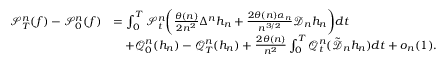Convert formula to latex. <formula><loc_0><loc_0><loc_500><loc_500>\begin{array} { r l } { \ m a t h s c r { S } _ { T } ^ { n } ( f ) - \ m a t h s c r { S } _ { 0 } ^ { n } ( f ) } & { = \int _ { 0 } ^ { T } \ m a t h s c r { S } _ { t } ^ { n } \left ( \frac { \theta ( n ) } { 2 n ^ { 2 } } \Delta ^ { n } h _ { n } + \frac { 2 \theta ( n ) \alpha _ { n } } { n ^ { 3 / 2 } } \ m a t h s c r { D } _ { n } h _ { n } \right ) d t } \\ & { \quad + \ m a t h s c r { Q } _ { 0 } ^ { n } ( h _ { n } ) - \ m a t h s c r { Q } _ { T } ^ { n } ( h _ { n } ) + \frac { 2 \theta ( n ) } { n ^ { 2 } } \int _ { 0 } ^ { T } \ m a t h s c r { Q } _ { t } ^ { n } ( \tilde { \ m a t h s c r { D } } _ { n } h _ { n } ) d t + o _ { n } ( 1 ) . } \end{array}</formula> 